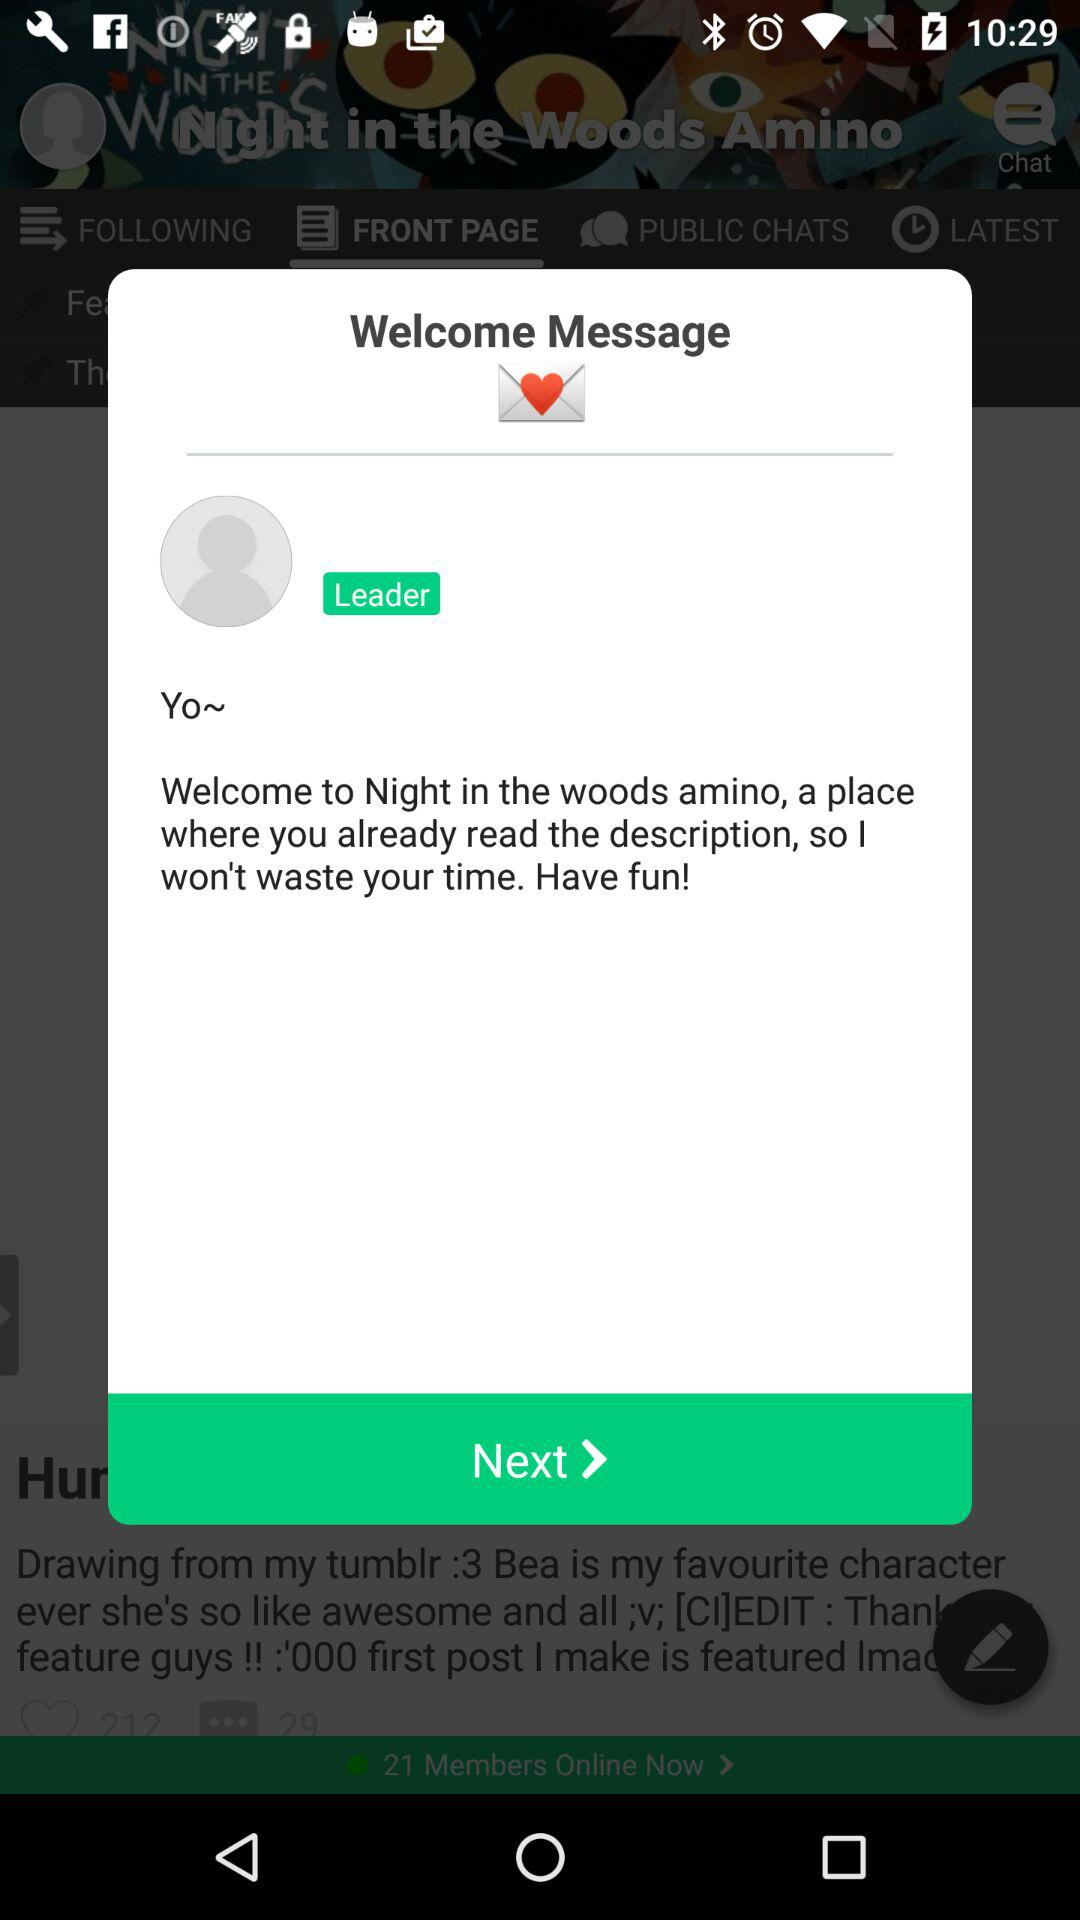What is the profile name? The profile name is Yo. 